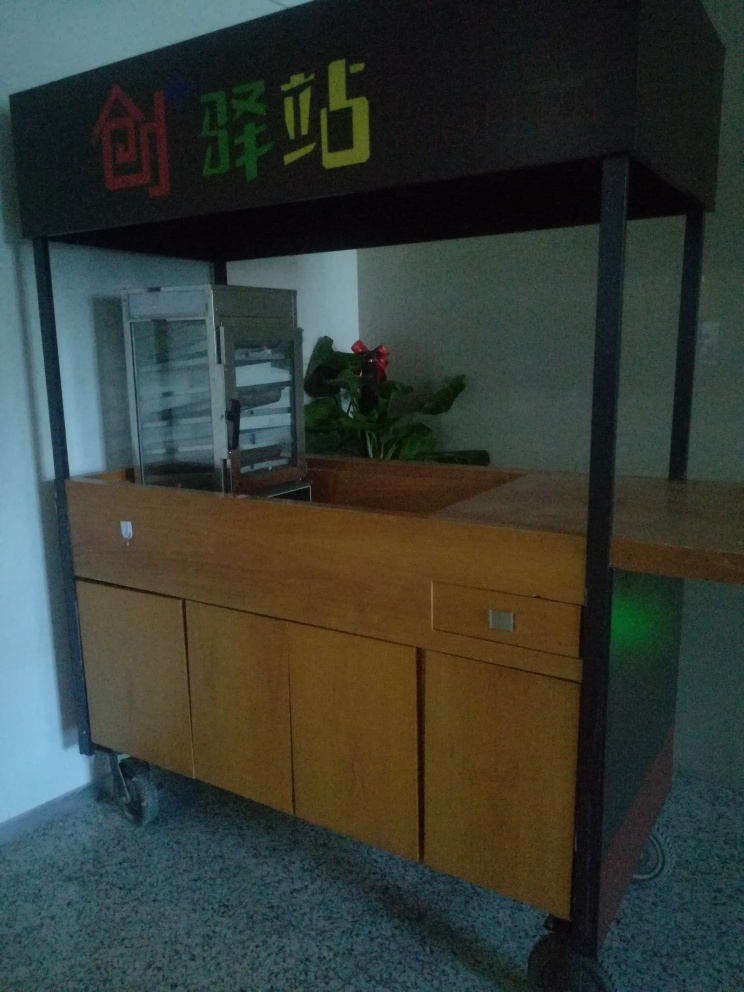What is the state of the background in the image?
A. Clear and crisp
B. Sharp and focused
C. Slightly blurred
Answer with the option's letter from the given choices directly.
 C. 